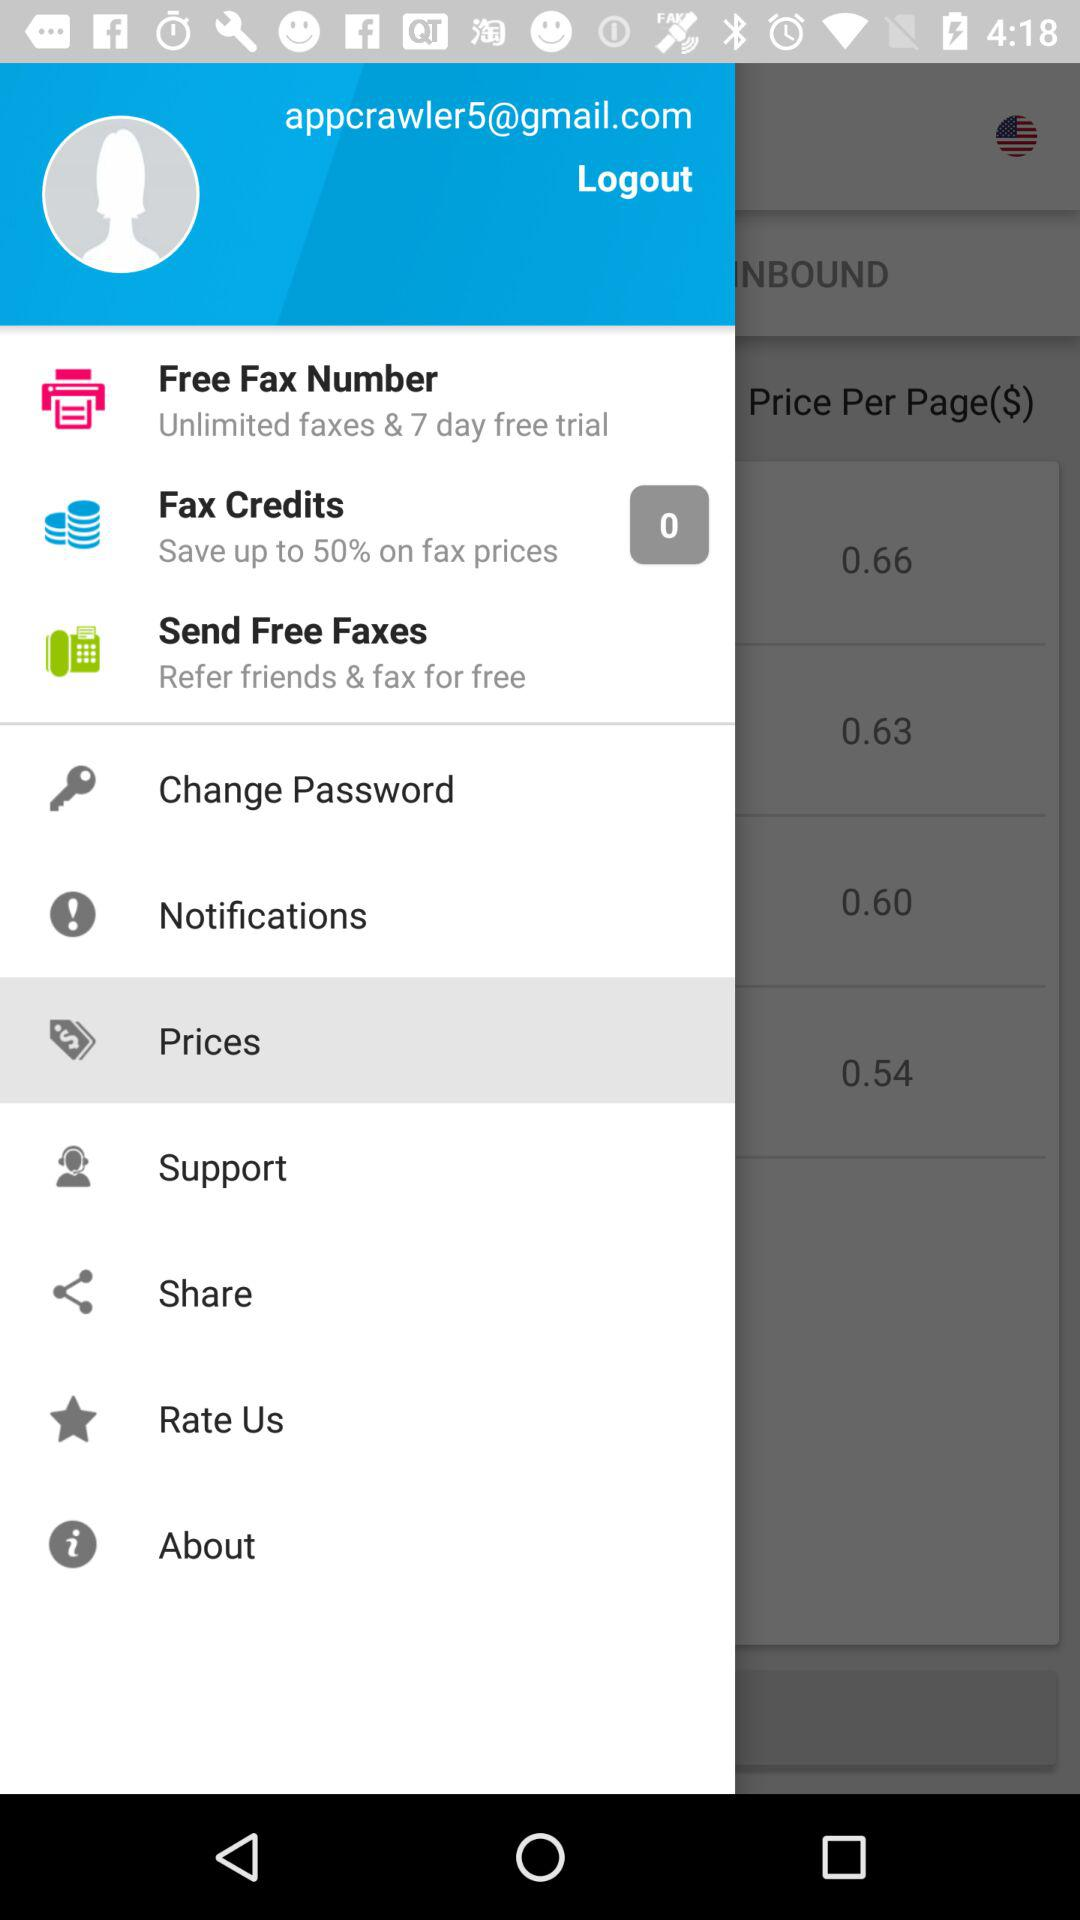What is the email address of the user? The email address of the user is appcrawler5@gmail.com. 